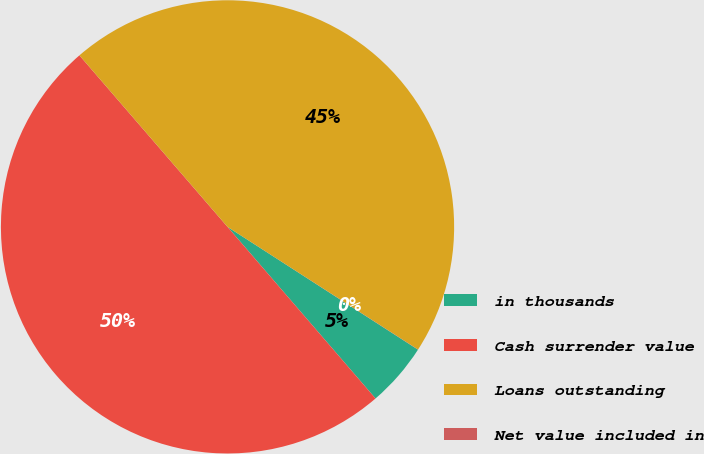Convert chart to OTSL. <chart><loc_0><loc_0><loc_500><loc_500><pie_chart><fcel>in thousands<fcel>Cash surrender value<fcel>Loans outstanding<fcel>Net value included in<nl><fcel>4.56%<fcel>49.99%<fcel>45.44%<fcel>0.01%<nl></chart> 